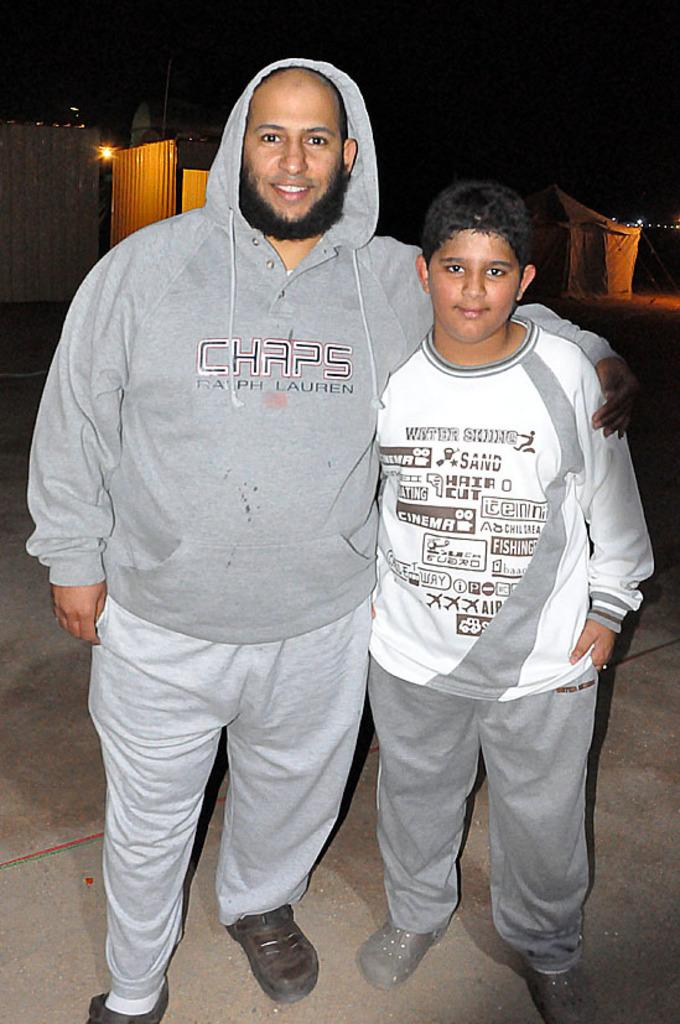How many people are in the foreground of the picture? There are two people standing in the foreground of the picture. What can be seen in the background of the picture? There are buildings, lights, and other objects in the background of the picture. Can you see a baseball game happening in the picture? There is no indication of a baseball game or any baseball-related objects in the picture. 